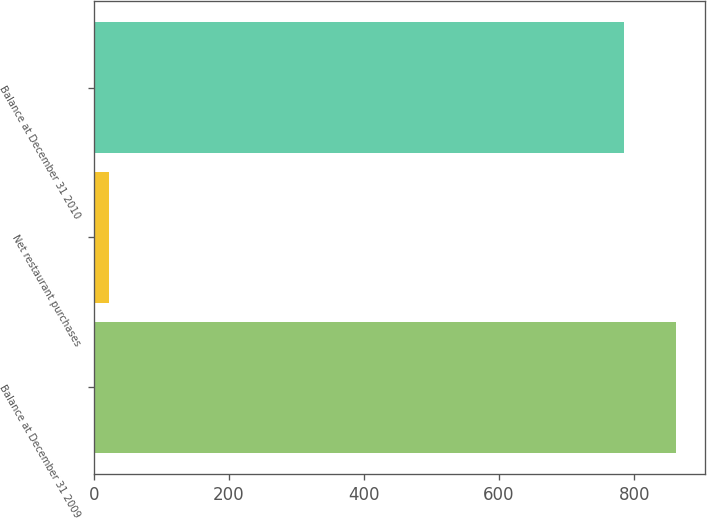Convert chart to OTSL. <chart><loc_0><loc_0><loc_500><loc_500><bar_chart><fcel>Balance at December 31 2009<fcel>Net restaurant purchases<fcel>Balance at December 31 2010<nl><fcel>862.27<fcel>23<fcel>785.5<nl></chart> 